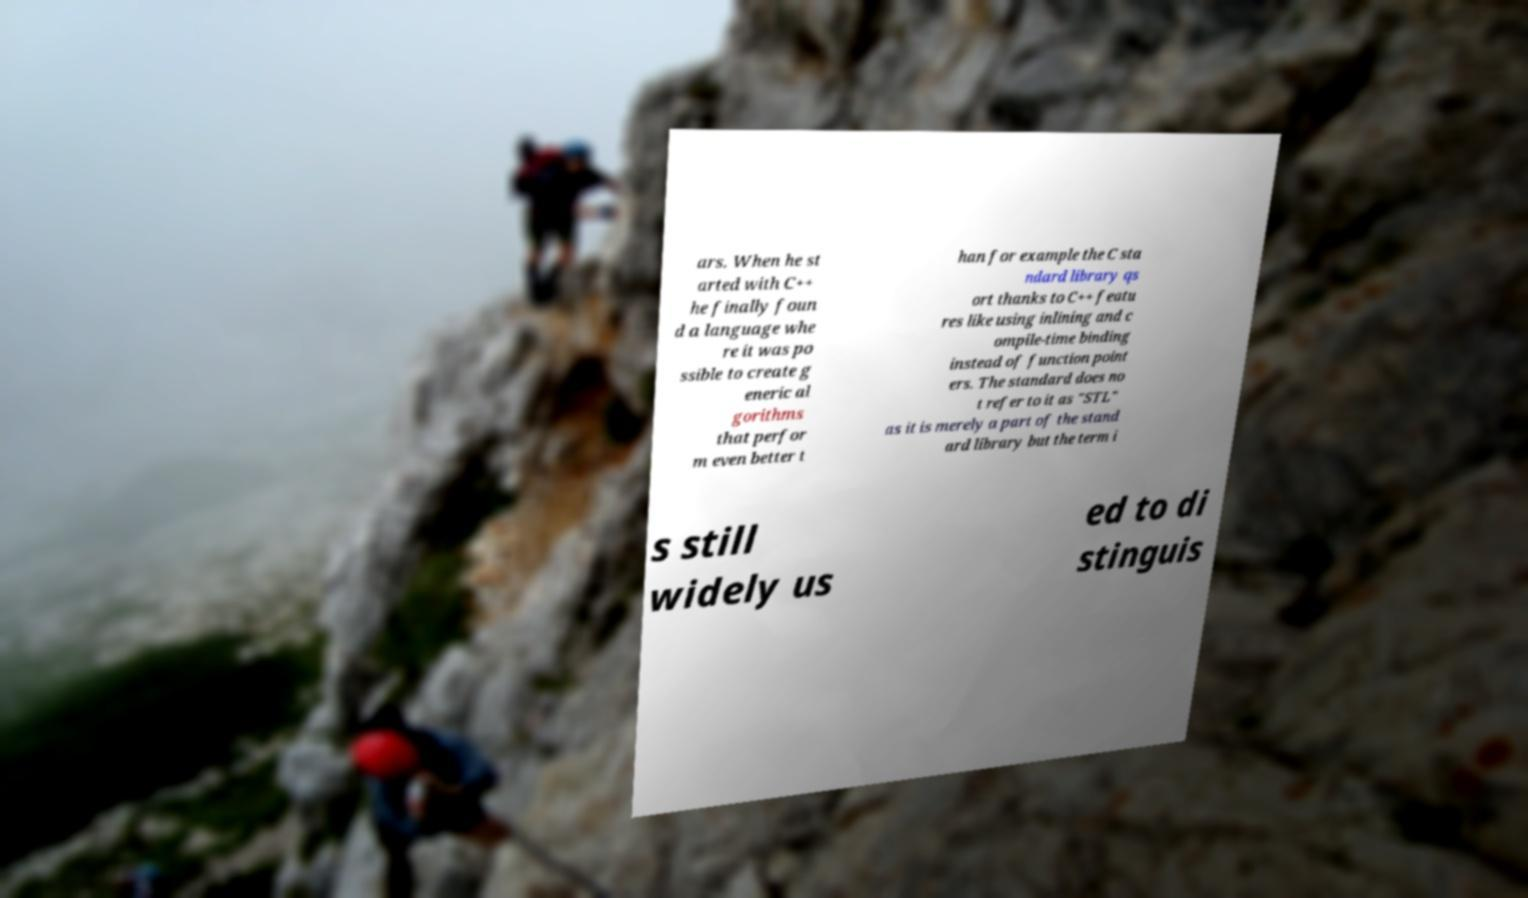Can you accurately transcribe the text from the provided image for me? ars. When he st arted with C++ he finally foun d a language whe re it was po ssible to create g eneric al gorithms that perfor m even better t han for example the C sta ndard library qs ort thanks to C++ featu res like using inlining and c ompile-time binding instead of function point ers. The standard does no t refer to it as "STL" as it is merely a part of the stand ard library but the term i s still widely us ed to di stinguis 